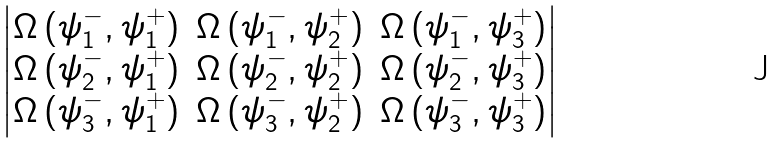<formula> <loc_0><loc_0><loc_500><loc_500>\begin{vmatrix} \Omega \, ( \psi _ { 1 } ^ { - } , \psi _ { 1 } ^ { + } ) & \Omega \, ( \psi _ { 1 } ^ { - } , \psi _ { 2 } ^ { + } ) & \Omega \, ( \psi _ { 1 } ^ { - } , \psi _ { 3 } ^ { + } ) \\ \Omega \, ( \psi _ { 2 } ^ { - } , \psi _ { 1 } ^ { + } ) & \Omega \, ( \psi _ { 2 } ^ { - } , \psi _ { 2 } ^ { + } ) & \Omega \, ( \psi _ { 2 } ^ { - } , \psi _ { 3 } ^ { + } ) \\ \Omega \, ( \psi _ { 3 } ^ { - } , \psi _ { 1 } ^ { + } ) & \Omega \, ( \psi _ { 3 } ^ { - } , \psi _ { 2 } ^ { + } ) & \Omega \, ( \psi _ { 3 } ^ { - } , \psi _ { 3 } ^ { + } ) \end{vmatrix}</formula> 